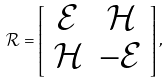Convert formula to latex. <formula><loc_0><loc_0><loc_500><loc_500>\mathcal { R } = \left [ \begin{array} { c c } \mathcal { E } & \mathcal { H } \\ \mathcal { H } & - \mathcal { E } \end{array} \right ] ,</formula> 